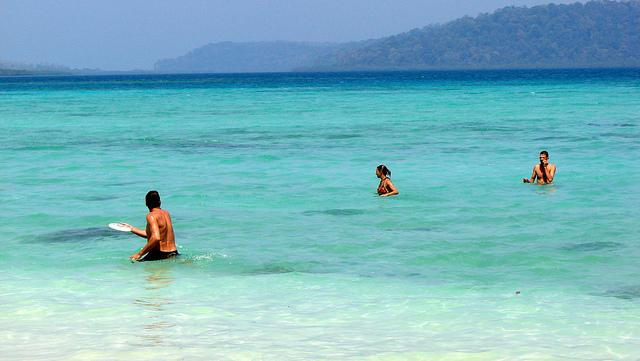What is the man in deep water about to catch? Please explain your reasoning. frisbee. There is a frisbee being thrown from one person to the other. the catcher will catch the thrower's frisbee. 